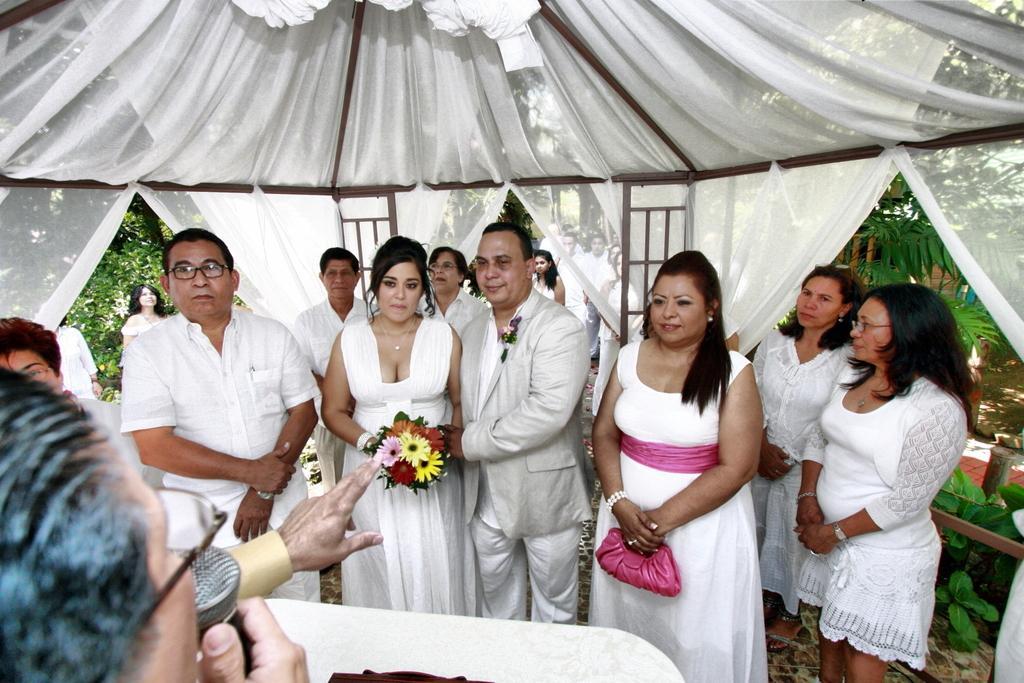Please provide a concise description of this image. In this image we can see few persons are standing under a tent like structure where we can see clothes on the poles and among them a woman is holding flower bouquet in her hands and another woman is holding a bag in her hands. At the bottom we can see a person is holding a mic in the hand. In the background there are few persons, plants and trees. 